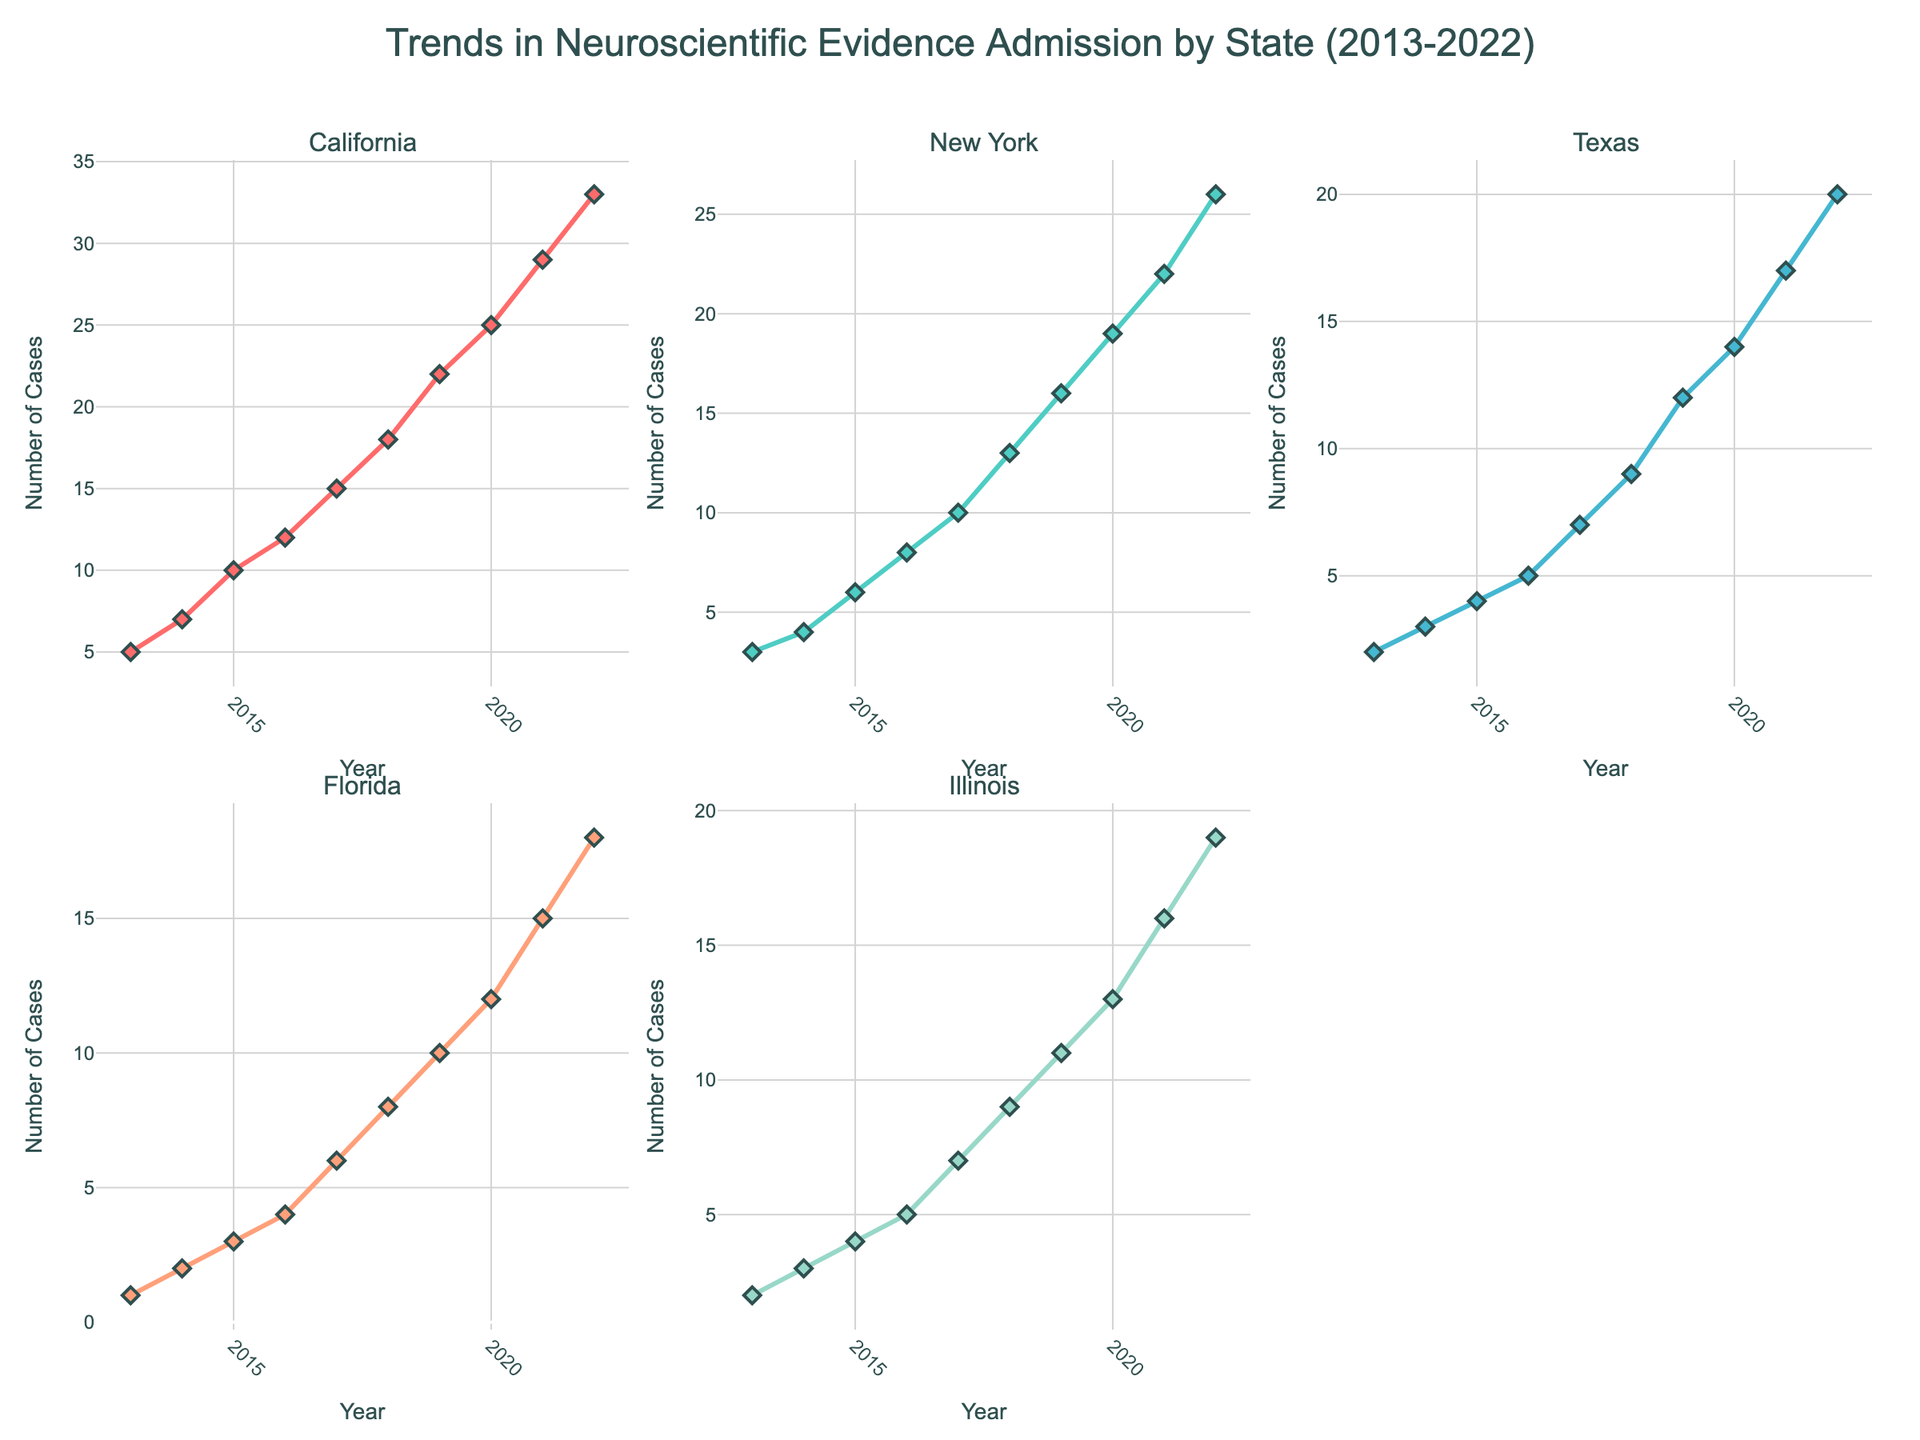What's the title of the figure? The title is located at the top center of the figure and reads "Trends in Neuroscientific Evidence Admission by State (2013-2022)".
Answer: Trends in Neuroscientific Evidence Admission by State (2013-2022) Which state had the highest number of cases using neuroscientific evidence in 2022? Look at the plot for each state in the second subplot row to identify which has the highest y-value in 2022. California reaches the top value of 33.
Answer: California How many cases were there in Texas in 2015? Find the subplot for Texas, then locate the point where the year is 2015 on the x-axis and see the corresponding y-value. There were 4 cases in Texas in 2015.
Answer: 4 Compare the number of cases in New York and Florida in 2019. Which state had more? Look at the plots for New York and Florida for the year 2019. New York shows 16 cases while Florida shows 10 cases. New York had more cases.
Answer: New York What's the general trend observed for the admission of neuroscientific evidence in criminal trials over the past decade? Evaluate the slope or general direction of the lines in each subplot. All states show an increasing trend over time.
Answer: Increasing trend In which year did Illinois see its sharpest increase in the number of cases? Examine the Illinois plot and identify the year where the slope is the steepest. The sharpest increase in Illinois occurred between 2016 and 2017.
Answer: 2017 What is the average number of cases across all states in 2020? Sum the number of cases for California (25), New York (19), Texas (14), Florida (12), Illinois (13) and divide by the number of states (5). (25+19+14+12+13)/5 = 16.6
Answer: 16.6 Between 2013 and 2017, which state experienced the most significant rise in case numbers? Compare the difference in cases from 2013 to 2017 for each state: California (15-5=10), New York (10-3=7), Texas (7-2=5), Florida (6-1=5), Illinois (7-2=5). California has the largest increase of 10.
Answer: California By 2021, how many states had more than 15 cases involving neuroscientific evidence? Review each subplot's y-value in 2021 and count how many exceed 15. California (29), New York (22), Texas (17), and Florida (15). Three out of five states had more than 15 cases.
Answer: 3 